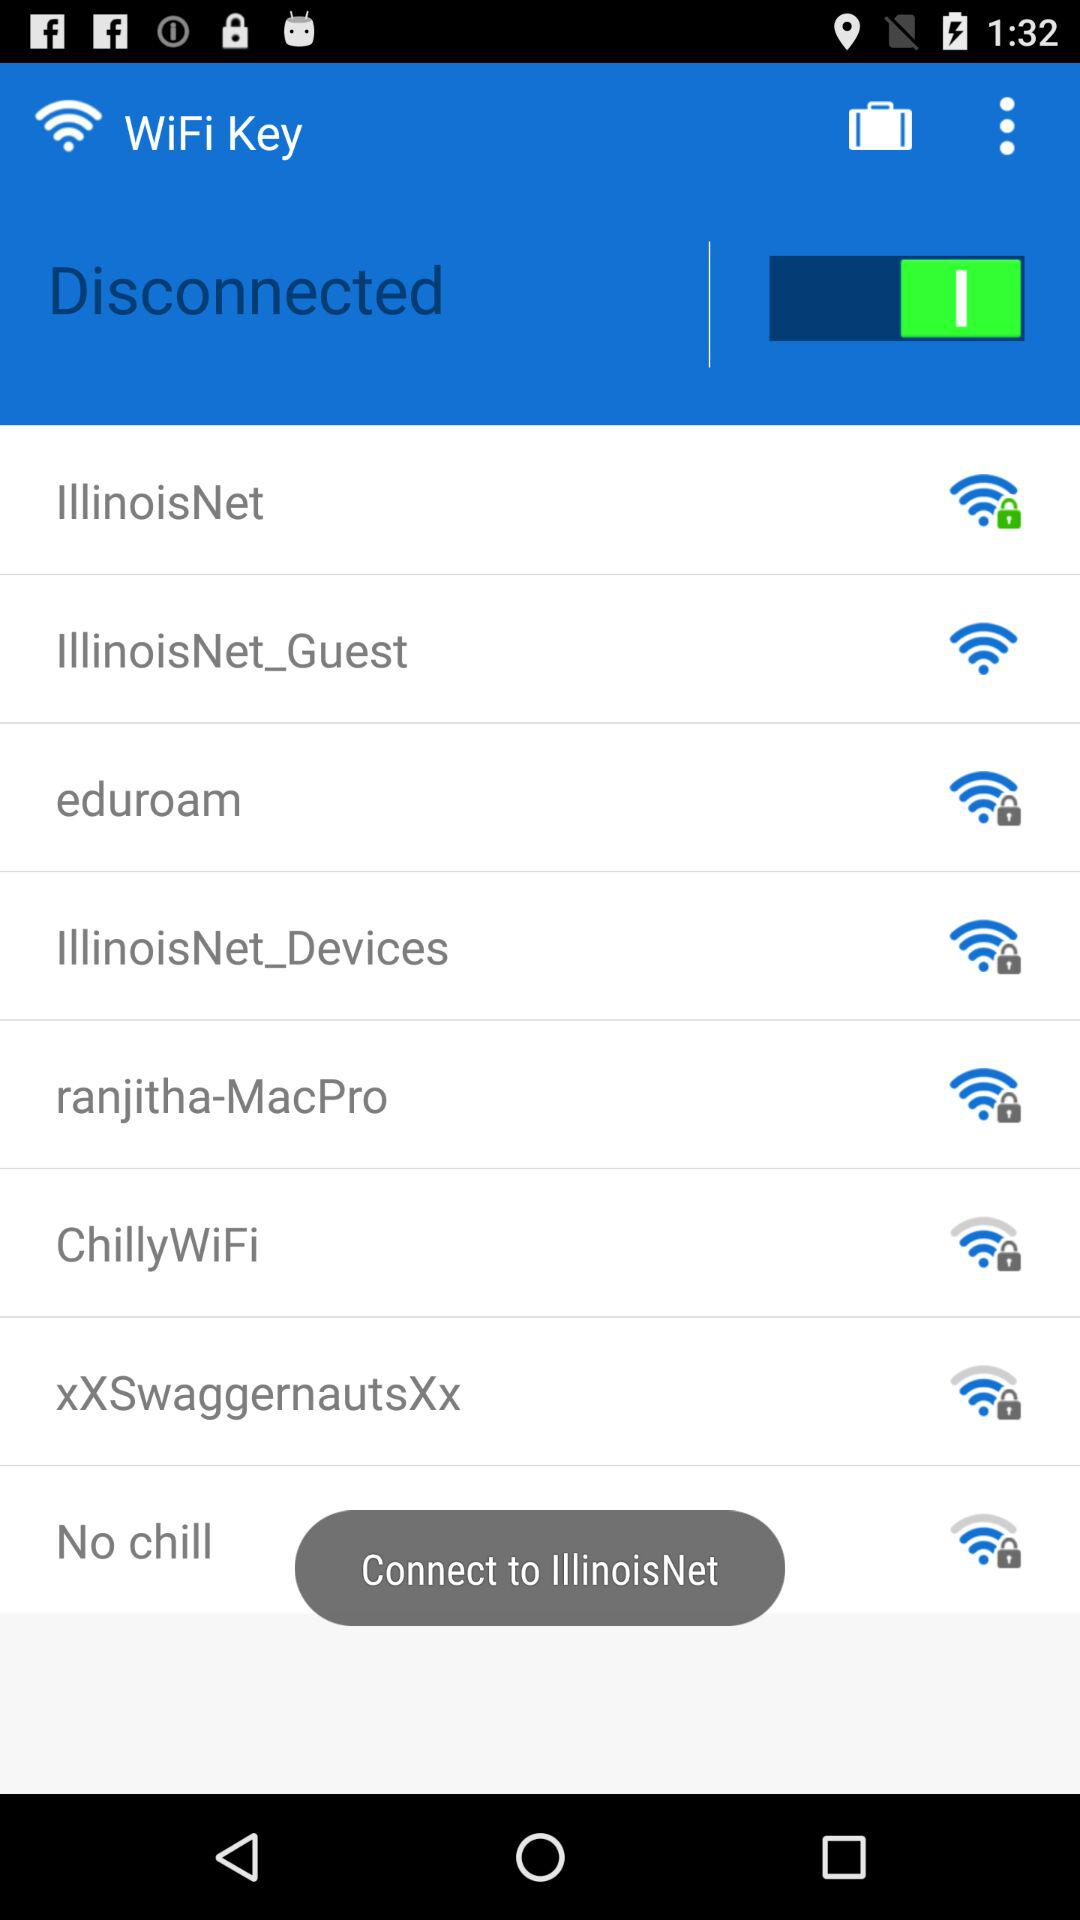What is the status of the "WiFi Key"? The status of the "WiFi Key" is disconnected. 